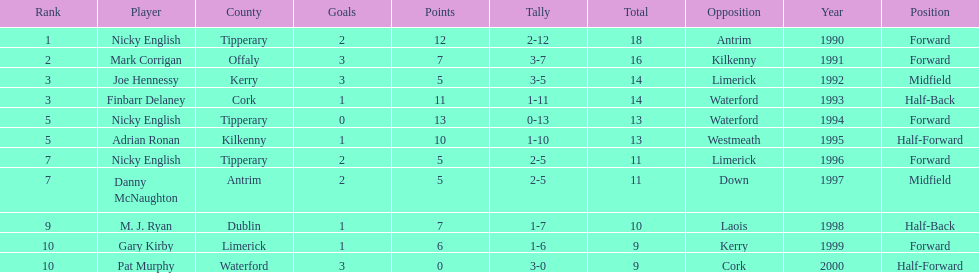Would you be able to parse every entry in this table? {'header': ['Rank', 'Player', 'County', 'Goals', 'Points', 'Tally', 'Total', 'Opposition', 'Year', 'Position'], 'rows': [['1', 'Nicky English', 'Tipperary', '2', '12', '2-12', '18', 'Antrim', '1990', 'Forward'], ['2', 'Mark Corrigan', 'Offaly', '3', '7', '3-7', '16', 'Kilkenny', '1991', 'Forward'], ['3', 'Joe Hennessy', 'Kerry', '3', '5', '3-5', '14', 'Limerick', '1992', 'Midfield'], ['3', 'Finbarr Delaney', 'Cork', '1', '11', '1-11', '14', 'Waterford', '1993', 'Half-Back'], ['5', 'Nicky English', 'Tipperary', '0', '13', '0-13', '13', 'Waterford', '1994', 'Forward'], ['5', 'Adrian Ronan', 'Kilkenny', '1', '10', '1-10', '13', 'Westmeath', '1995', 'Half-Forward'], ['7', 'Nicky English', 'Tipperary', '2', '5', '2-5', '11', 'Limerick', '1996', 'Forward'], ['7', 'Danny McNaughton', 'Antrim', '2', '5', '2-5', '11', 'Down', '1997', 'Midfield'], ['9', 'M. J. Ryan', 'Dublin', '1', '7', '1-7', '10', 'Laois', '1998', 'Half-Back'], ['10', 'Gary Kirby', 'Limerick', '1', '6', '1-6', '9', 'Kerry', '1999', 'Forward'], ['10', 'Pat Murphy', 'Waterford', '3', '0', '3-0', '9', 'Cork', '2000', 'Half-Forward']]} How many people are on the list? 9. 